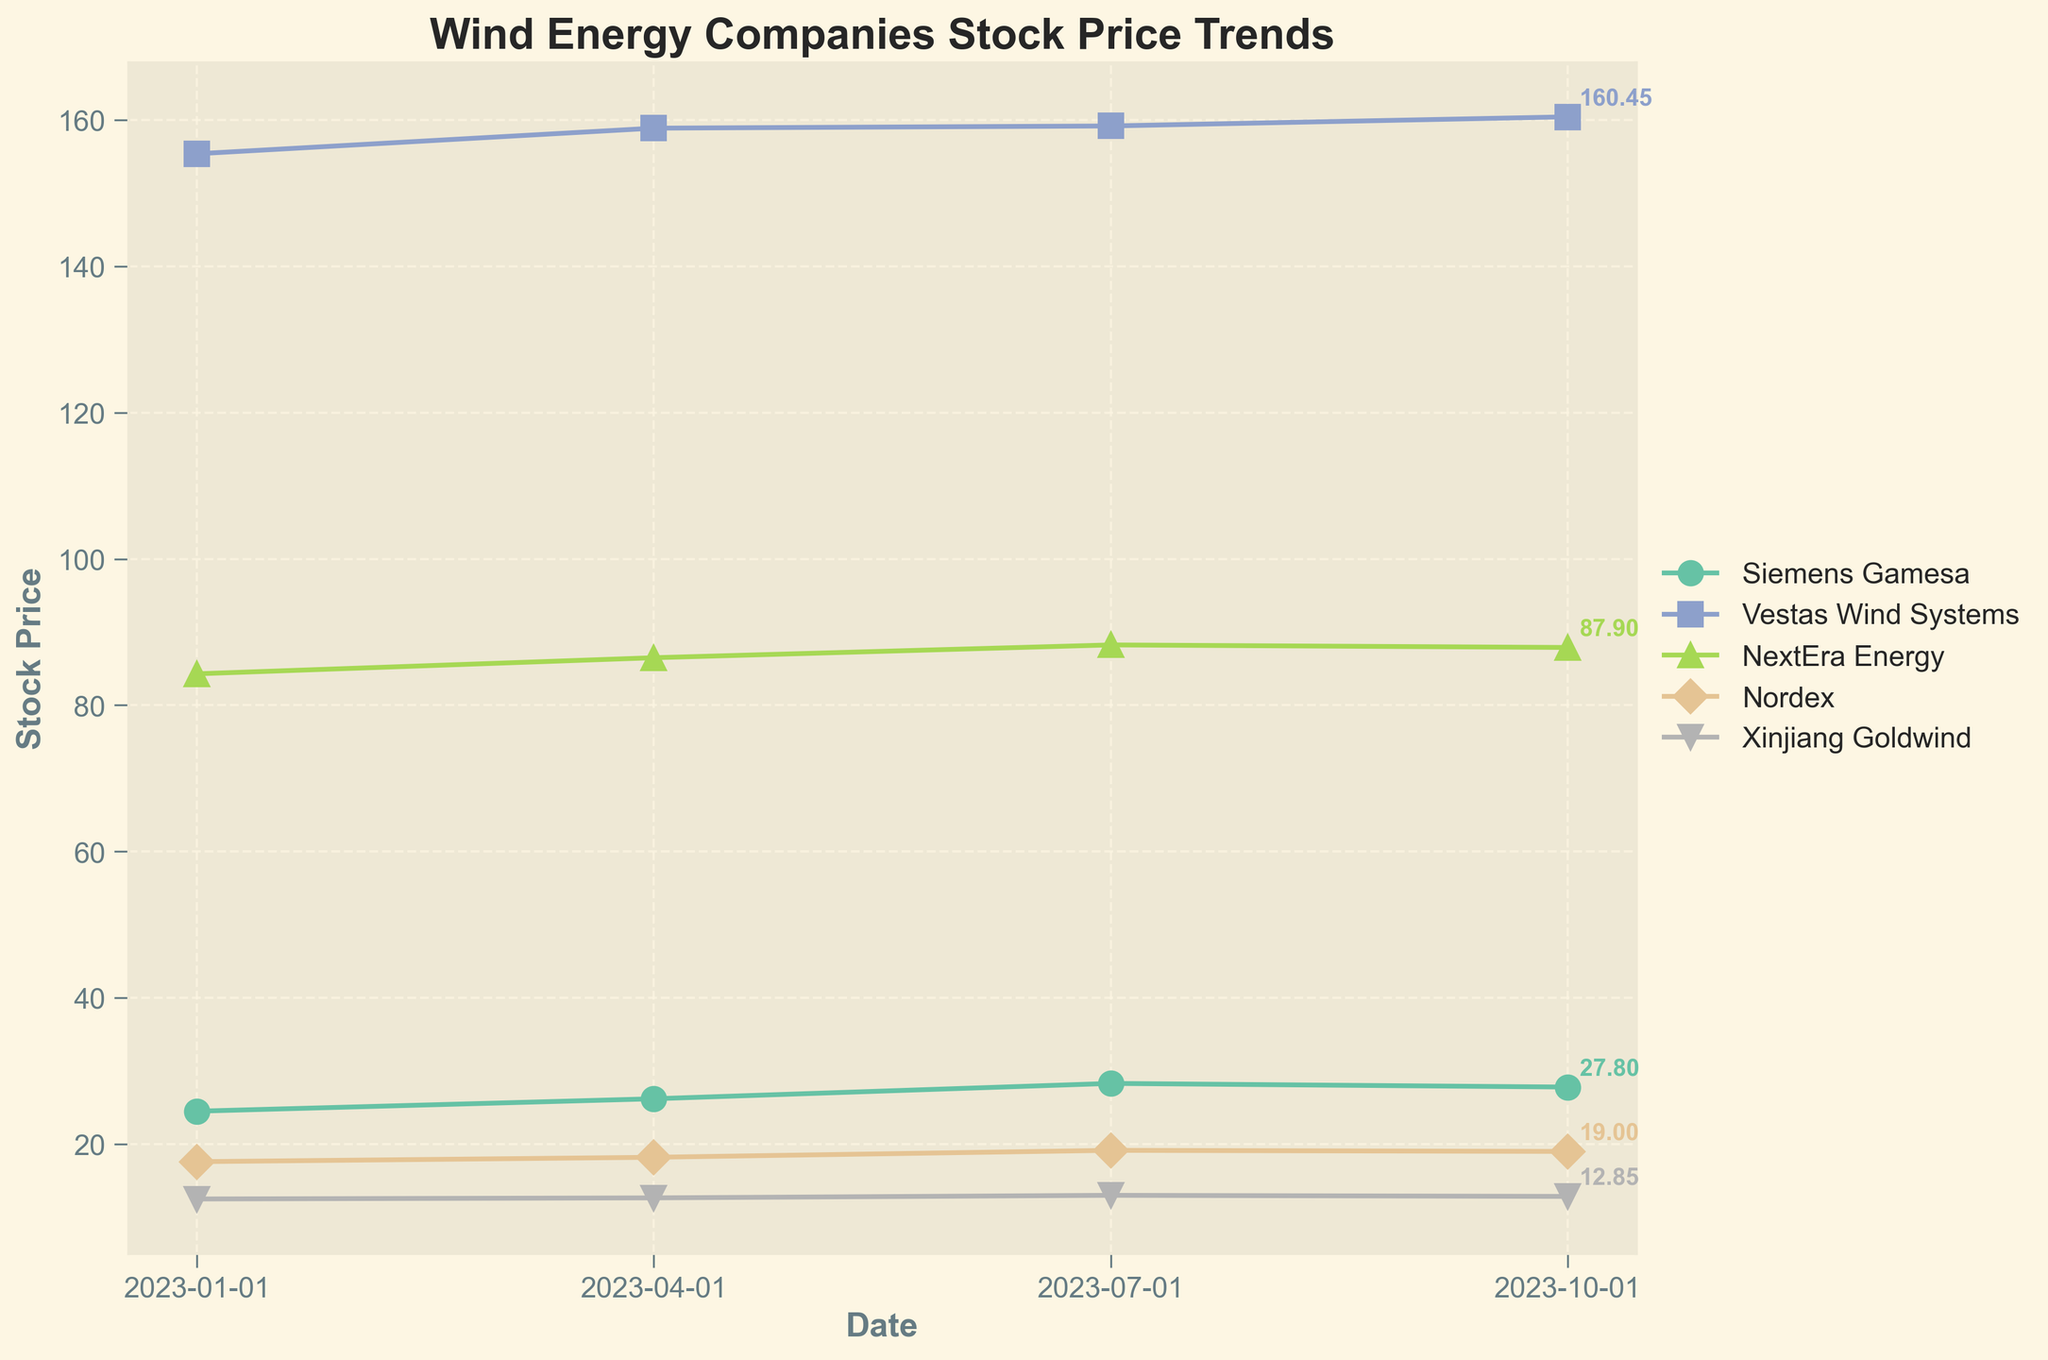What is the title of the plot? The title of the plot is typically located at the top center of the figure and provides a brief description of what the plot represents.
Answer: Wind Energy Companies Stock Price Trends What are the companies represented in the plot? The different lines in the plot, distinguished by various colors and markers, represent the companies. The legend on the right side of the plot identifies these companies.
Answer: Siemens Gamesa, Vestas Wind Systems, NextEra Energy, Nordex, Xinjiang Goldwind Which company has the highest stock price in Autumn 2023? By observing the endpoints of the lines in the plot for Autumn 2023, you can identify the company with the highest stock price.
Answer: Vestas Wind Systems What is the trend of Siemens Gamesa's stock price throughout 2023? Look at the line representing Siemens Gamesa and observe how it changes across the four seasons on the x-axis. Siemens Gamesa's stock price starts at 24.50 in Winter, increases to 26.20 in Spring, rises further to 28.30 in Summer, and slightly drops to 27.80 in Autumn.
Answer: Increasing trend, slight decrease in Autumn Compare the stock price trends of Vestas Wind Systems and Nordex across 2023. Observe and compare the lines for Vestas Wind Systems and Nordex. Vestas Wind Systems starts at 155.40 in Winter and steadily increases to 160.45 in Autumn. Nordex starts at 17.60 in Winter, increases to 19.15 in Summer, and slightly drops to 19.00 in Autumn.
Answer: Vestas Wind Systems shows a steady increase, Nordex shows a growth then slight decrease What is the average stock price of NextEra Energy for 2023? Sum the stock prices of NextEra Energy for Winter, Spring, Summer, and Autumn, then divide by 4. (84.30 + 86.50 + 88.25 + 87.90) / 4 = 86.74
Answer: 86.74 Which company had the greatest increase in stock price from Winter to Spring 2023? Calculate the difference between the Winter and Spring stock prices for each company and compare the differences. Siemens Gamesa: 26.20 - 24.50 = 1.70, Vestas Wind Systems: 158.90 - 155.40 = 3.50, NextEra Energy: 86.50 - 84.30 = 2.20, Nordex: 18.20 - 17.60 = 0.60, Xinjiang Goldwind: 12.65 - 12.50 = 0.15. The greatest increase is for Vestas Wind Systems with a difference of 3.50.
Answer: Vestas Wind Systems Describe the relationship between average wind speed and stock price for Siemens Gamesa. Compare the average wind speed and stock price data points for Siemens Gamesa across the seasons: Winter (8.5, 24.50), Spring (12.3, 26.20), Summer (10.1, 28.30), Autumn (15.5, 27.80). Higher average wind speeds in Spring and Autumn accompany higher stock prices.
Answer: Positive correlation, higher wind speeds generally correspond to higher stock prices Which geographic location has the company with the highest stock price in Summer 2023? Identify the company with the highest stock price in Summer 2023 and note its geographic location from the data. Vestas Wind Systems has a stock price of 159.20 in Summer, located in Europe.
Answer: Europe What is the general trend of Xinjiang Goldwind's stock price across 2023? Observe the line representing Xinjiang Goldwind and describe how it changes from Winter to Autumn. Xinjiang Goldwind's stock price starts at 12.50 in Winter, increases slightly through Spring and Summer, and slightly drops in Autumn.
Answer: Slight increase, slight decrease in Autumn 